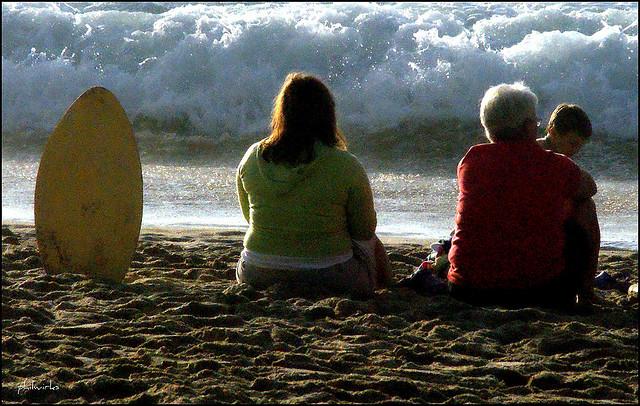Will the wave wash over these people?
Answer briefly. No. Is the man wearing glasses?
Concise answer only. Yes. What is sticking up from the sand?
Quick response, please. Surfboard. 